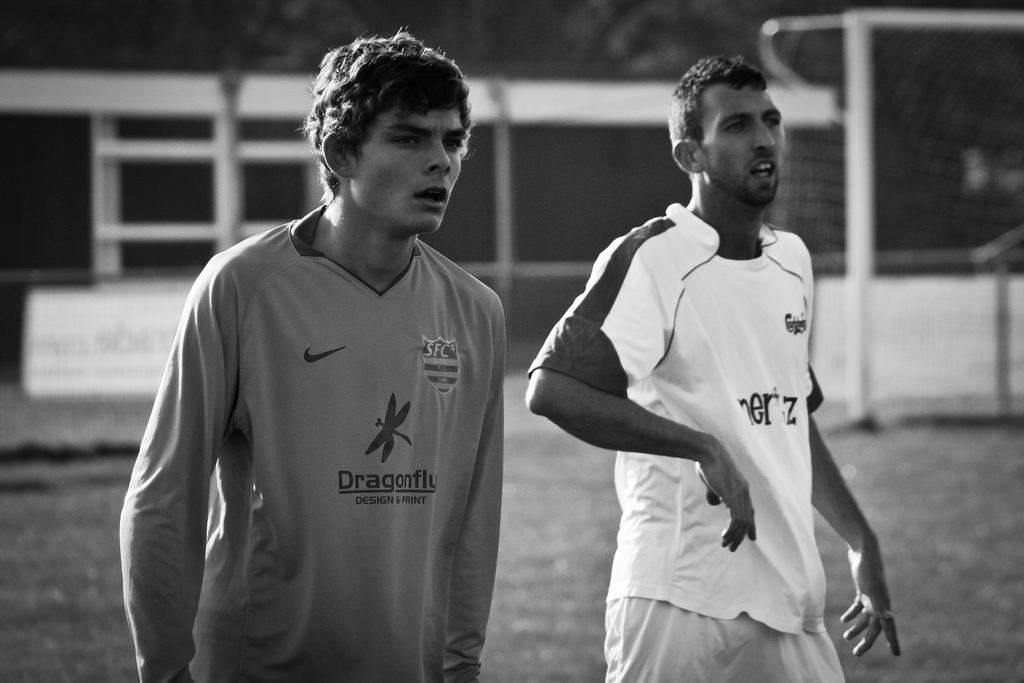What is the color scheme of the image? The image is black and white. white. How many people are in the image? There are two men in the image. Can you describe the background of the image? The background is blurred. What objects can be seen in the image besides the men? There are poles in the image. What time of day is it in the image, considering it's a night scene? The image is not a night scene, as it is black and white, and there is no mention of nighttime in the provided facts. 